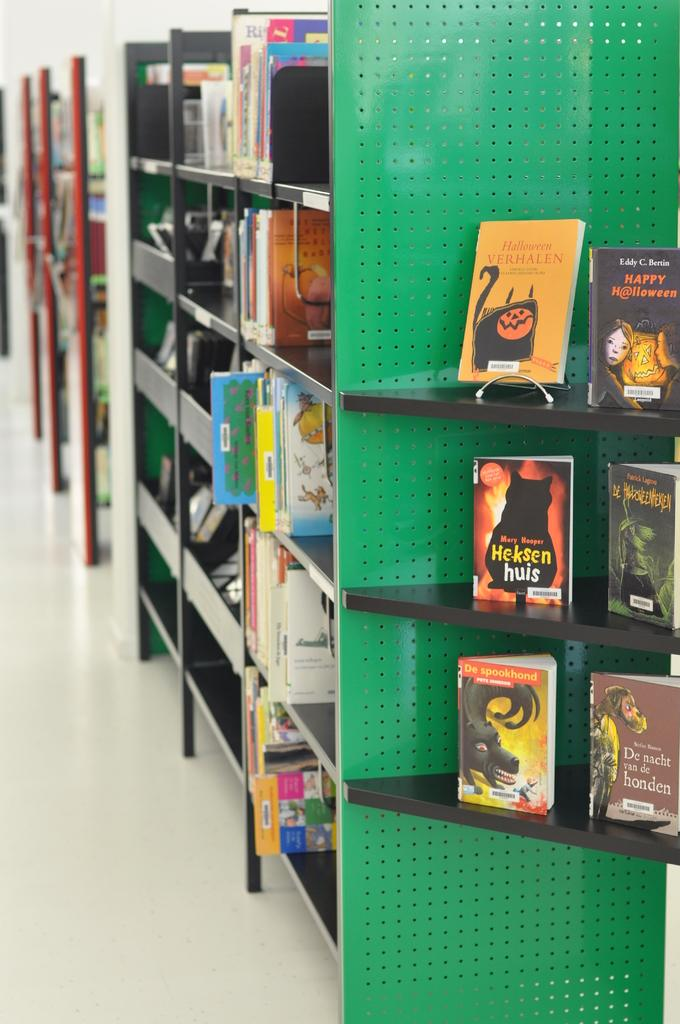<image>
Render a clear and concise summary of the photo. halloween books are dispalyed on the book shelf at the library 